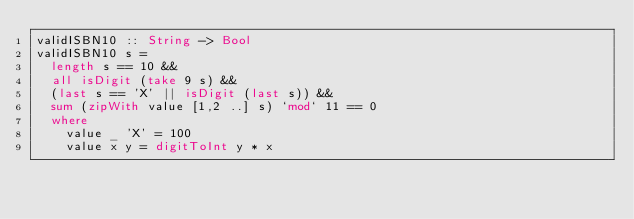<code> <loc_0><loc_0><loc_500><loc_500><_Haskell_>validISBN10 :: String -> Bool
validISBN10 s =
  length s == 10 &&
  all isDigit (take 9 s) &&
  (last s == 'X' || isDigit (last s)) &&
  sum (zipWith value [1,2 ..] s) `mod` 11 == 0
  where
    value _ 'X' = 100
    value x y = digitToInt y * x
</code> 